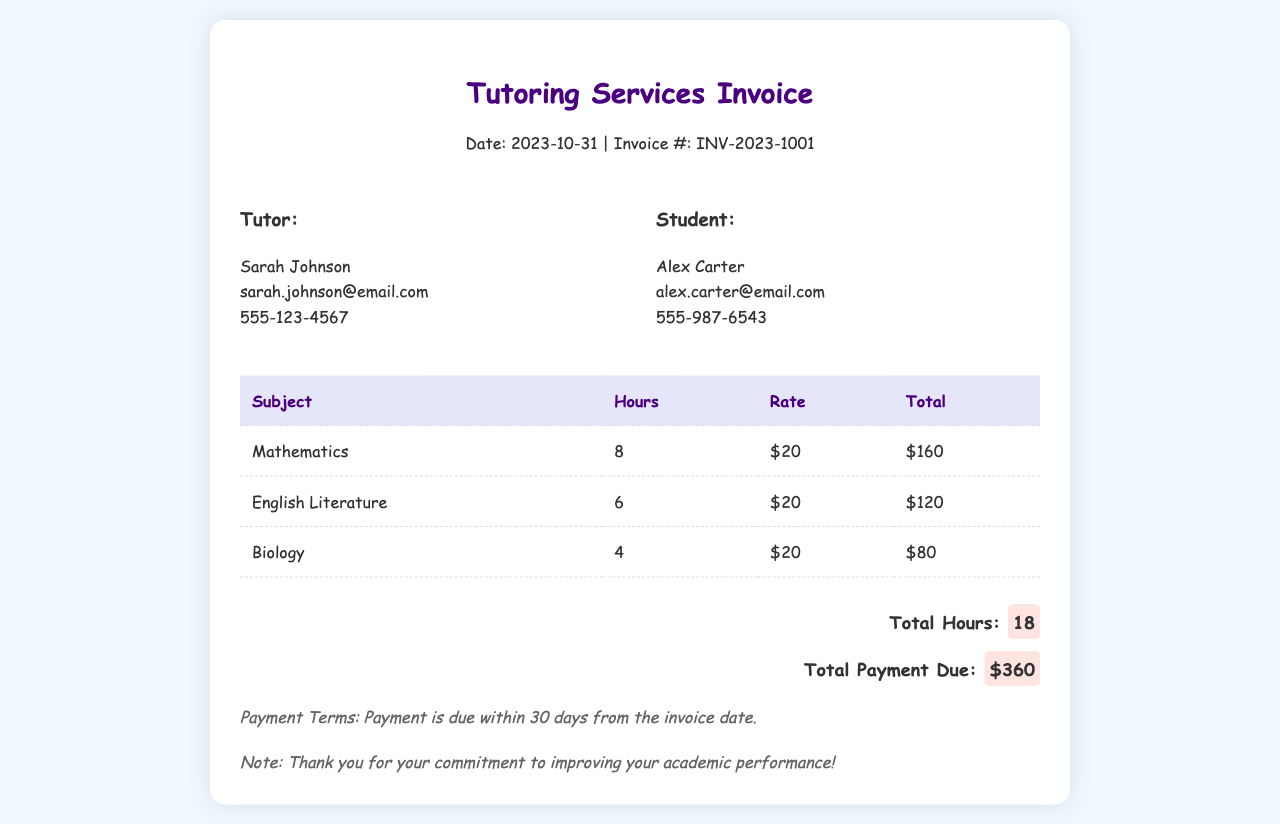What is the invoice date? The invoice date is stated in the header section of the document.
Answer: 2023-10-31 Who is the tutor? The tutor's name and contact information are provided under the tutor details.
Answer: Sarah Johnson How many hours of Mathematics tutoring were billed? The table lists the hours for each subject, including Mathematics.
Answer: 8 What is the hourly rate for the tutoring services? The hourly rate is consistently mentioned in the table and applies to all subjects.
Answer: $20 What is the total payment due? The total payment due is summarized at the bottom of the document.
Answer: $360 How many subjects are listed in the invoice? The table contains a row for each subject tutored over the past month.
Answer: 3 What is the total number of hours billed? The total hours are calculated by summing the hours from each subject in the table.
Answer: 18 What payment term is mentioned in the document? The payment terms are outlined at the end of the invoice.
Answer: Due within 30 days What note is included in the invoice? A note expressing gratitude is included near the end of the document.
Answer: Thank you for your commitment to improving your academic performance! 